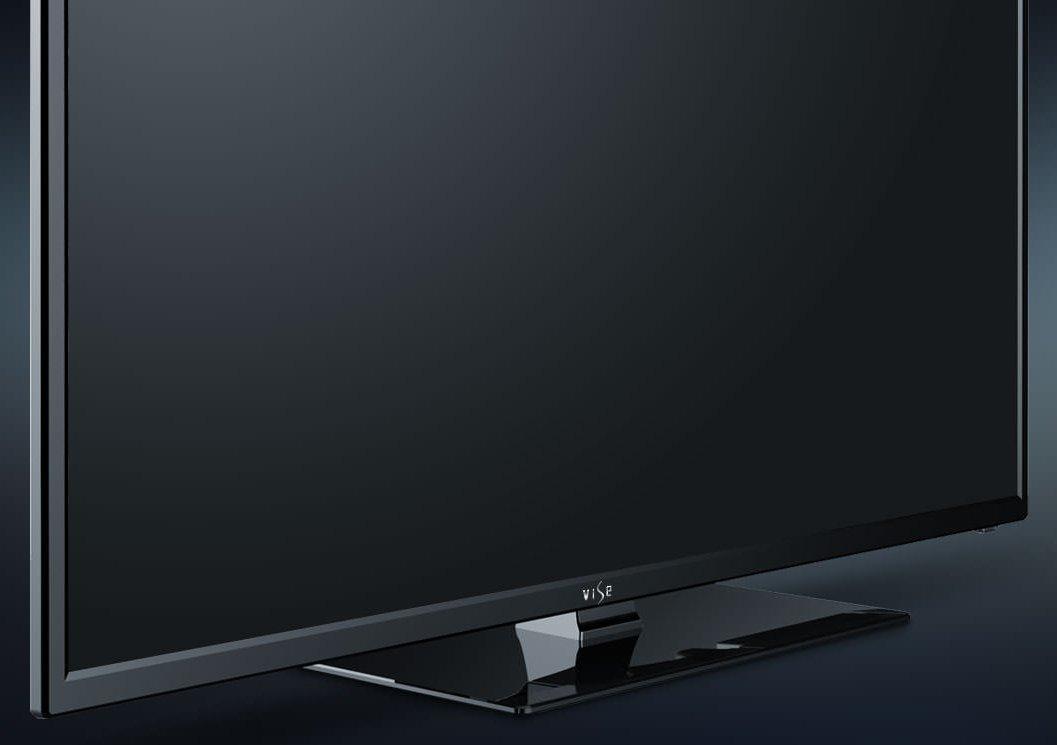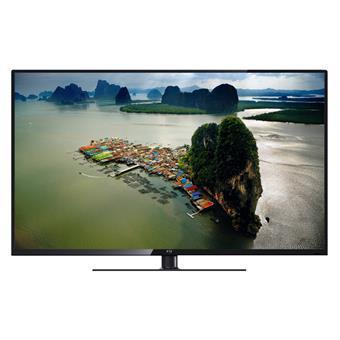The first image is the image on the left, the second image is the image on the right. Examine the images to the left and right. Is the description "The television on the left has leg stands." accurate? Answer yes or no. No. The first image is the image on the left, the second image is the image on the right. Analyze the images presented: Is the assertion "there is a sun glare in a monitor" valid? Answer yes or no. No. 